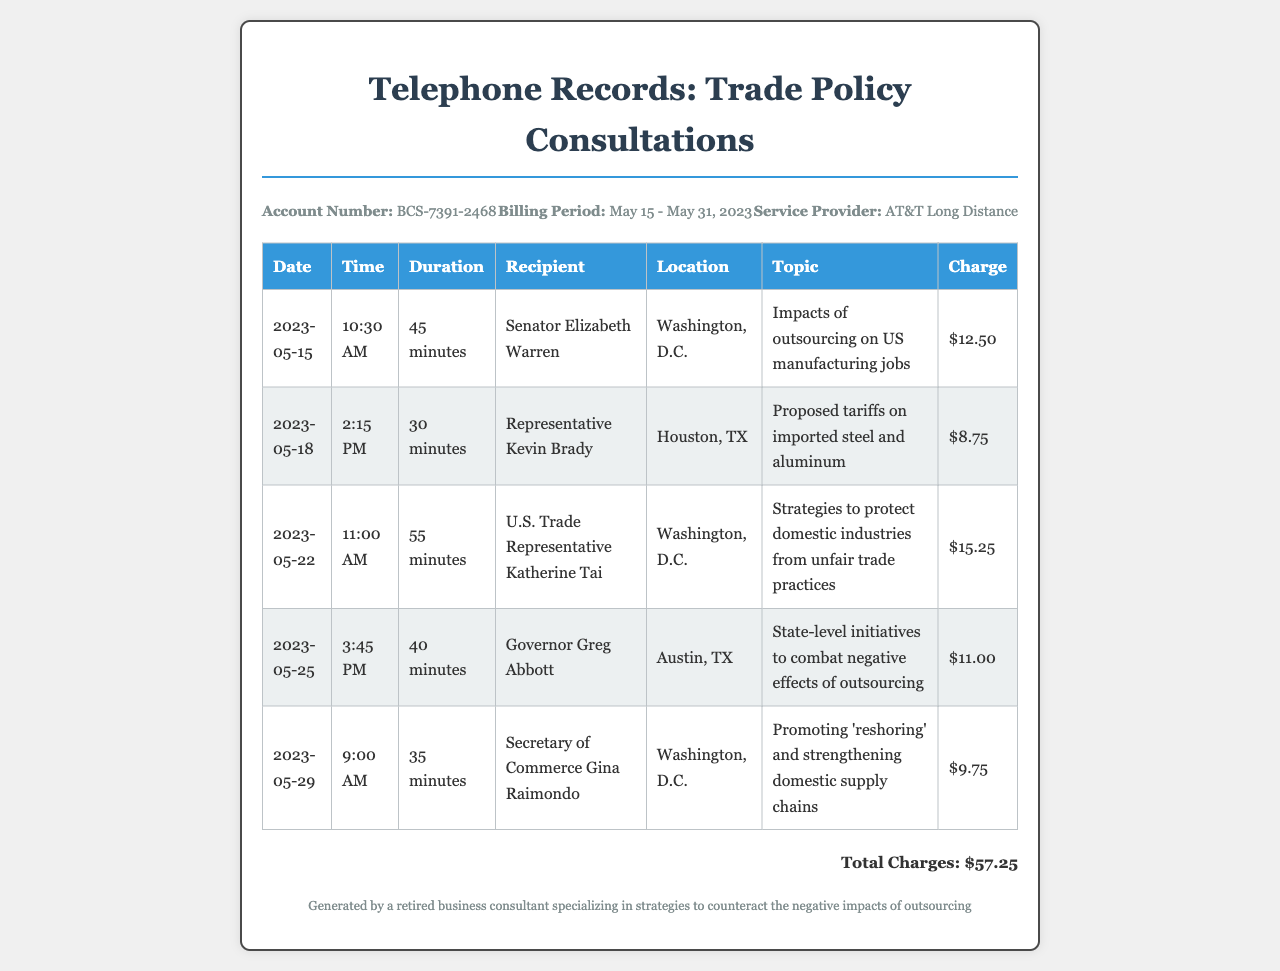What is the account number? The account number is found in the header information of the document.
Answer: BCS-7391-2468 What is the total charge for the calls? The total charge is the sum of all the individual call charges listed in the table.
Answer: $57.25 Who did the longest call go to? The longest call can be identified by comparing the duration of all the calls in the records.
Answer: U.S. Trade Representative Katherine Tai On what date was the call with Senator Elizabeth Warren made? The date of the call with Senator Elizabeth Warren is listed in the table under that specific recipient.
Answer: 2023-05-15 What was the topic of the call with Secretary of Commerce Gina Raimondo? The topic is specified in the table next to the date and recipient of the call.
Answer: Promoting 'reshoring' and strengthening domestic supply chains How many minutes was the call with Representative Kevin Brady? The duration of the call is explicitly stated in the table in the duration column for that recipient.
Answer: 30 minutes Which state official was consulted regarding outsourcing effects? The individual consulted is noted alongside their title and location in the records table.
Answer: Governor Greg Abbott What time was the call with U.S. Trade Representative Katherine Tai? The time of the call is specified in the table corresponding to that discussion.
Answer: 11:00 AM 